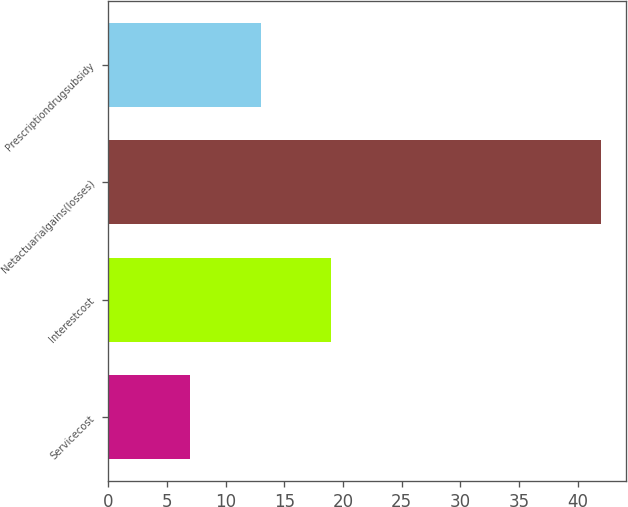Convert chart. <chart><loc_0><loc_0><loc_500><loc_500><bar_chart><fcel>Servicecost<fcel>Interestcost<fcel>Netactuarialgains(losses)<fcel>Prescriptiondrugsubsidy<nl><fcel>7<fcel>19<fcel>42<fcel>13<nl></chart> 